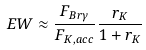<formula> <loc_0><loc_0><loc_500><loc_500>E W \approx \frac { F _ { B r \gamma } } { F _ { K , a c c } } \frac { r _ { K } } { 1 + r _ { K } }</formula> 